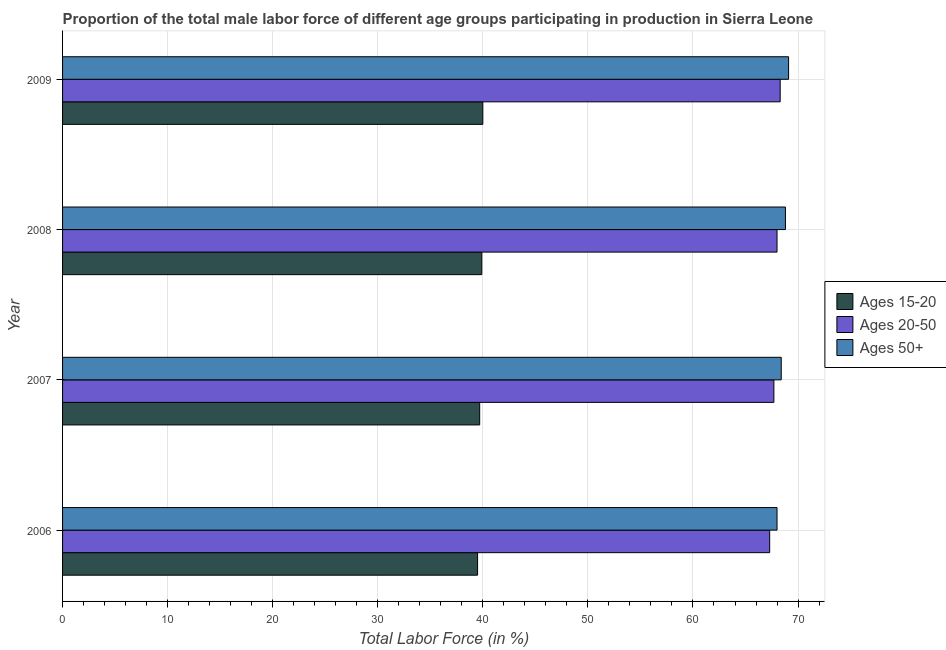How many different coloured bars are there?
Give a very brief answer. 3. How many bars are there on the 4th tick from the top?
Your answer should be very brief. 3. What is the percentage of male labor force within the age group 15-20 in 2009?
Your response must be concise. 40. Across all years, what is the maximum percentage of male labor force above age 50?
Make the answer very short. 69.1. Across all years, what is the minimum percentage of male labor force within the age group 20-50?
Provide a succinct answer. 67.3. In which year was the percentage of male labor force above age 50 maximum?
Make the answer very short. 2009. In which year was the percentage of male labor force within the age group 20-50 minimum?
Your response must be concise. 2006. What is the total percentage of male labor force within the age group 20-50 in the graph?
Ensure brevity in your answer.  271.3. What is the difference between the percentage of male labor force within the age group 20-50 in 2008 and that in 2009?
Your response must be concise. -0.3. What is the average percentage of male labor force within the age group 20-50 per year?
Provide a short and direct response. 67.83. In the year 2009, what is the difference between the percentage of male labor force within the age group 15-20 and percentage of male labor force above age 50?
Provide a short and direct response. -29.1. Is the percentage of male labor force within the age group 15-20 in 2006 less than that in 2008?
Keep it short and to the point. Yes. What does the 1st bar from the top in 2009 represents?
Make the answer very short. Ages 50+. What does the 3rd bar from the bottom in 2006 represents?
Provide a succinct answer. Ages 50+. Is it the case that in every year, the sum of the percentage of male labor force within the age group 15-20 and percentage of male labor force within the age group 20-50 is greater than the percentage of male labor force above age 50?
Keep it short and to the point. Yes. How many bars are there?
Your answer should be compact. 12. Are the values on the major ticks of X-axis written in scientific E-notation?
Ensure brevity in your answer.  No. Does the graph contain any zero values?
Offer a very short reply. No. Where does the legend appear in the graph?
Offer a terse response. Center right. How many legend labels are there?
Your answer should be compact. 3. How are the legend labels stacked?
Give a very brief answer. Vertical. What is the title of the graph?
Ensure brevity in your answer.  Proportion of the total male labor force of different age groups participating in production in Sierra Leone. Does "Ages 15-20" appear as one of the legend labels in the graph?
Keep it short and to the point. Yes. What is the label or title of the X-axis?
Your response must be concise. Total Labor Force (in %). What is the label or title of the Y-axis?
Offer a very short reply. Year. What is the Total Labor Force (in %) in Ages 15-20 in 2006?
Ensure brevity in your answer.  39.5. What is the Total Labor Force (in %) in Ages 20-50 in 2006?
Your response must be concise. 67.3. What is the Total Labor Force (in %) in Ages 50+ in 2006?
Give a very brief answer. 68. What is the Total Labor Force (in %) of Ages 15-20 in 2007?
Give a very brief answer. 39.7. What is the Total Labor Force (in %) in Ages 20-50 in 2007?
Your answer should be very brief. 67.7. What is the Total Labor Force (in %) in Ages 50+ in 2007?
Your answer should be very brief. 68.4. What is the Total Labor Force (in %) in Ages 15-20 in 2008?
Provide a short and direct response. 39.9. What is the Total Labor Force (in %) in Ages 20-50 in 2008?
Keep it short and to the point. 68. What is the Total Labor Force (in %) in Ages 50+ in 2008?
Keep it short and to the point. 68.8. What is the Total Labor Force (in %) of Ages 15-20 in 2009?
Offer a very short reply. 40. What is the Total Labor Force (in %) in Ages 20-50 in 2009?
Give a very brief answer. 68.3. What is the Total Labor Force (in %) in Ages 50+ in 2009?
Provide a succinct answer. 69.1. Across all years, what is the maximum Total Labor Force (in %) of Ages 15-20?
Give a very brief answer. 40. Across all years, what is the maximum Total Labor Force (in %) in Ages 20-50?
Provide a succinct answer. 68.3. Across all years, what is the maximum Total Labor Force (in %) in Ages 50+?
Make the answer very short. 69.1. Across all years, what is the minimum Total Labor Force (in %) of Ages 15-20?
Offer a terse response. 39.5. Across all years, what is the minimum Total Labor Force (in %) of Ages 20-50?
Provide a short and direct response. 67.3. What is the total Total Labor Force (in %) in Ages 15-20 in the graph?
Your answer should be compact. 159.1. What is the total Total Labor Force (in %) in Ages 20-50 in the graph?
Ensure brevity in your answer.  271.3. What is the total Total Labor Force (in %) in Ages 50+ in the graph?
Offer a very short reply. 274.3. What is the difference between the Total Labor Force (in %) of Ages 15-20 in 2006 and that in 2007?
Your response must be concise. -0.2. What is the difference between the Total Labor Force (in %) in Ages 20-50 in 2006 and that in 2007?
Give a very brief answer. -0.4. What is the difference between the Total Labor Force (in %) in Ages 50+ in 2006 and that in 2007?
Offer a terse response. -0.4. What is the difference between the Total Labor Force (in %) of Ages 15-20 in 2006 and that in 2008?
Give a very brief answer. -0.4. What is the difference between the Total Labor Force (in %) of Ages 20-50 in 2006 and that in 2008?
Make the answer very short. -0.7. What is the difference between the Total Labor Force (in %) in Ages 15-20 in 2006 and that in 2009?
Your response must be concise. -0.5. What is the difference between the Total Labor Force (in %) in Ages 20-50 in 2006 and that in 2009?
Give a very brief answer. -1. What is the difference between the Total Labor Force (in %) of Ages 50+ in 2006 and that in 2009?
Your answer should be compact. -1.1. What is the difference between the Total Labor Force (in %) in Ages 50+ in 2007 and that in 2008?
Ensure brevity in your answer.  -0.4. What is the difference between the Total Labor Force (in %) in Ages 15-20 in 2007 and that in 2009?
Provide a short and direct response. -0.3. What is the difference between the Total Labor Force (in %) of Ages 20-50 in 2007 and that in 2009?
Provide a short and direct response. -0.6. What is the difference between the Total Labor Force (in %) in Ages 50+ in 2007 and that in 2009?
Make the answer very short. -0.7. What is the difference between the Total Labor Force (in %) in Ages 15-20 in 2008 and that in 2009?
Keep it short and to the point. -0.1. What is the difference between the Total Labor Force (in %) of Ages 50+ in 2008 and that in 2009?
Provide a succinct answer. -0.3. What is the difference between the Total Labor Force (in %) of Ages 15-20 in 2006 and the Total Labor Force (in %) of Ages 20-50 in 2007?
Keep it short and to the point. -28.2. What is the difference between the Total Labor Force (in %) in Ages 15-20 in 2006 and the Total Labor Force (in %) in Ages 50+ in 2007?
Your answer should be very brief. -28.9. What is the difference between the Total Labor Force (in %) in Ages 15-20 in 2006 and the Total Labor Force (in %) in Ages 20-50 in 2008?
Give a very brief answer. -28.5. What is the difference between the Total Labor Force (in %) of Ages 15-20 in 2006 and the Total Labor Force (in %) of Ages 50+ in 2008?
Your answer should be very brief. -29.3. What is the difference between the Total Labor Force (in %) in Ages 15-20 in 2006 and the Total Labor Force (in %) in Ages 20-50 in 2009?
Offer a terse response. -28.8. What is the difference between the Total Labor Force (in %) in Ages 15-20 in 2006 and the Total Labor Force (in %) in Ages 50+ in 2009?
Your answer should be compact. -29.6. What is the difference between the Total Labor Force (in %) of Ages 15-20 in 2007 and the Total Labor Force (in %) of Ages 20-50 in 2008?
Provide a succinct answer. -28.3. What is the difference between the Total Labor Force (in %) in Ages 15-20 in 2007 and the Total Labor Force (in %) in Ages 50+ in 2008?
Keep it short and to the point. -29.1. What is the difference between the Total Labor Force (in %) in Ages 15-20 in 2007 and the Total Labor Force (in %) in Ages 20-50 in 2009?
Ensure brevity in your answer.  -28.6. What is the difference between the Total Labor Force (in %) of Ages 15-20 in 2007 and the Total Labor Force (in %) of Ages 50+ in 2009?
Your response must be concise. -29.4. What is the difference between the Total Labor Force (in %) in Ages 20-50 in 2007 and the Total Labor Force (in %) in Ages 50+ in 2009?
Ensure brevity in your answer.  -1.4. What is the difference between the Total Labor Force (in %) of Ages 15-20 in 2008 and the Total Labor Force (in %) of Ages 20-50 in 2009?
Provide a short and direct response. -28.4. What is the difference between the Total Labor Force (in %) of Ages 15-20 in 2008 and the Total Labor Force (in %) of Ages 50+ in 2009?
Your answer should be compact. -29.2. What is the difference between the Total Labor Force (in %) of Ages 20-50 in 2008 and the Total Labor Force (in %) of Ages 50+ in 2009?
Your answer should be very brief. -1.1. What is the average Total Labor Force (in %) of Ages 15-20 per year?
Ensure brevity in your answer.  39.77. What is the average Total Labor Force (in %) of Ages 20-50 per year?
Ensure brevity in your answer.  67.83. What is the average Total Labor Force (in %) in Ages 50+ per year?
Give a very brief answer. 68.58. In the year 2006, what is the difference between the Total Labor Force (in %) of Ages 15-20 and Total Labor Force (in %) of Ages 20-50?
Offer a terse response. -27.8. In the year 2006, what is the difference between the Total Labor Force (in %) in Ages 15-20 and Total Labor Force (in %) in Ages 50+?
Provide a succinct answer. -28.5. In the year 2007, what is the difference between the Total Labor Force (in %) in Ages 15-20 and Total Labor Force (in %) in Ages 20-50?
Provide a succinct answer. -28. In the year 2007, what is the difference between the Total Labor Force (in %) in Ages 15-20 and Total Labor Force (in %) in Ages 50+?
Give a very brief answer. -28.7. In the year 2007, what is the difference between the Total Labor Force (in %) in Ages 20-50 and Total Labor Force (in %) in Ages 50+?
Provide a short and direct response. -0.7. In the year 2008, what is the difference between the Total Labor Force (in %) in Ages 15-20 and Total Labor Force (in %) in Ages 20-50?
Your answer should be very brief. -28.1. In the year 2008, what is the difference between the Total Labor Force (in %) in Ages 15-20 and Total Labor Force (in %) in Ages 50+?
Your answer should be compact. -28.9. In the year 2009, what is the difference between the Total Labor Force (in %) in Ages 15-20 and Total Labor Force (in %) in Ages 20-50?
Give a very brief answer. -28.3. In the year 2009, what is the difference between the Total Labor Force (in %) of Ages 15-20 and Total Labor Force (in %) of Ages 50+?
Your answer should be very brief. -29.1. What is the ratio of the Total Labor Force (in %) of Ages 20-50 in 2006 to that in 2007?
Your response must be concise. 0.99. What is the ratio of the Total Labor Force (in %) of Ages 15-20 in 2006 to that in 2008?
Provide a short and direct response. 0.99. What is the ratio of the Total Labor Force (in %) of Ages 50+ in 2006 to that in 2008?
Offer a terse response. 0.99. What is the ratio of the Total Labor Force (in %) in Ages 15-20 in 2006 to that in 2009?
Your response must be concise. 0.99. What is the ratio of the Total Labor Force (in %) of Ages 20-50 in 2006 to that in 2009?
Keep it short and to the point. 0.99. What is the ratio of the Total Labor Force (in %) in Ages 50+ in 2006 to that in 2009?
Offer a very short reply. 0.98. What is the ratio of the Total Labor Force (in %) of Ages 15-20 in 2007 to that in 2008?
Provide a short and direct response. 0.99. What is the ratio of the Total Labor Force (in %) of Ages 20-50 in 2007 to that in 2009?
Provide a short and direct response. 0.99. What is the ratio of the Total Labor Force (in %) of Ages 50+ in 2007 to that in 2009?
Offer a very short reply. 0.99. What is the ratio of the Total Labor Force (in %) in Ages 15-20 in 2008 to that in 2009?
Offer a very short reply. 1. What is the difference between the highest and the second highest Total Labor Force (in %) in Ages 15-20?
Give a very brief answer. 0.1. What is the difference between the highest and the second highest Total Labor Force (in %) in Ages 50+?
Make the answer very short. 0.3. What is the difference between the highest and the lowest Total Labor Force (in %) in Ages 20-50?
Give a very brief answer. 1. 